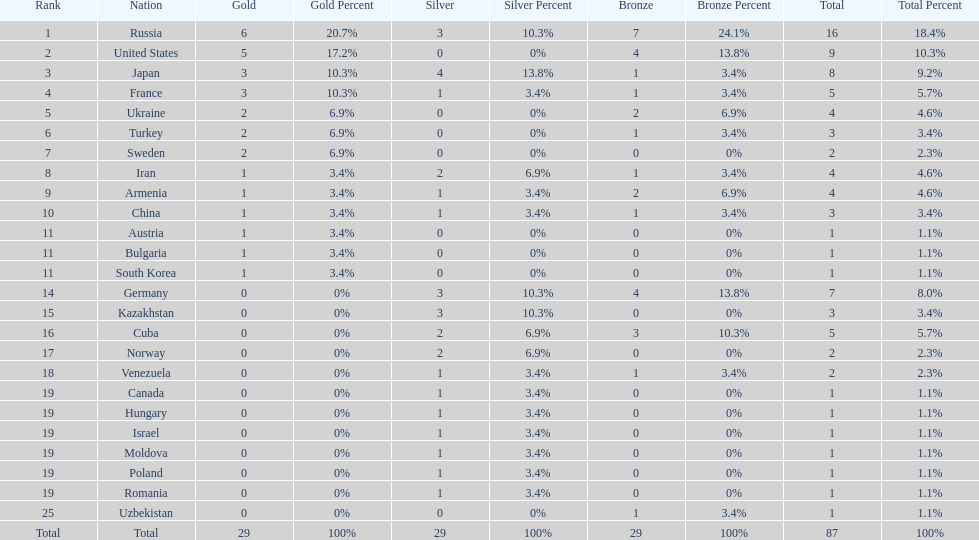How many silver medals did turkey win? 0. 